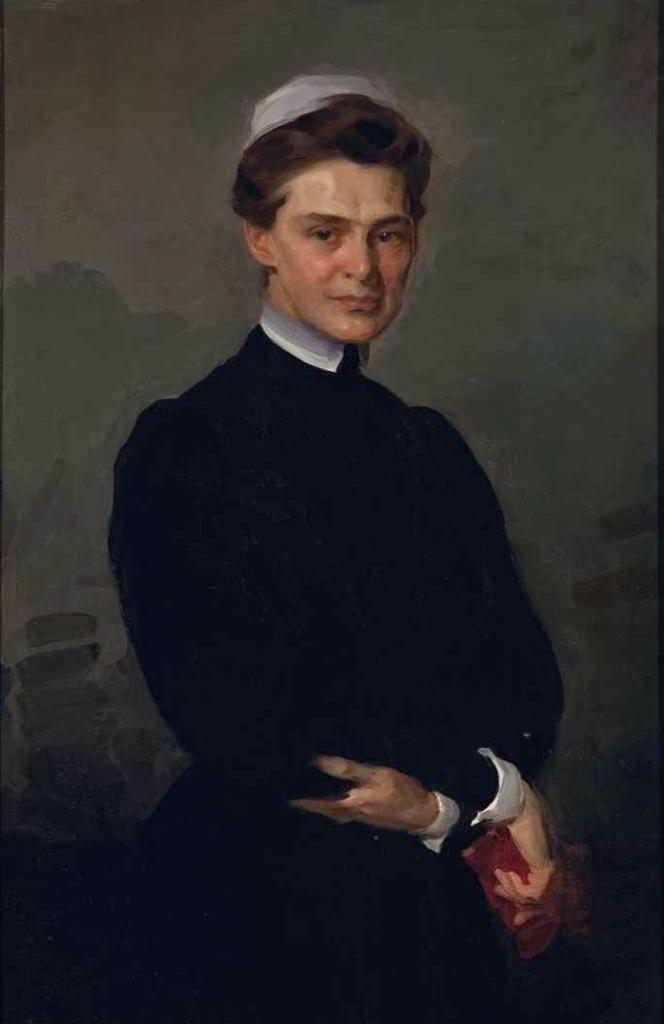Describe this image in one or two sentences. This image is a painting. In this painting we can see a lady standing. She is wearing a black dress. In the background we can see a wall. 